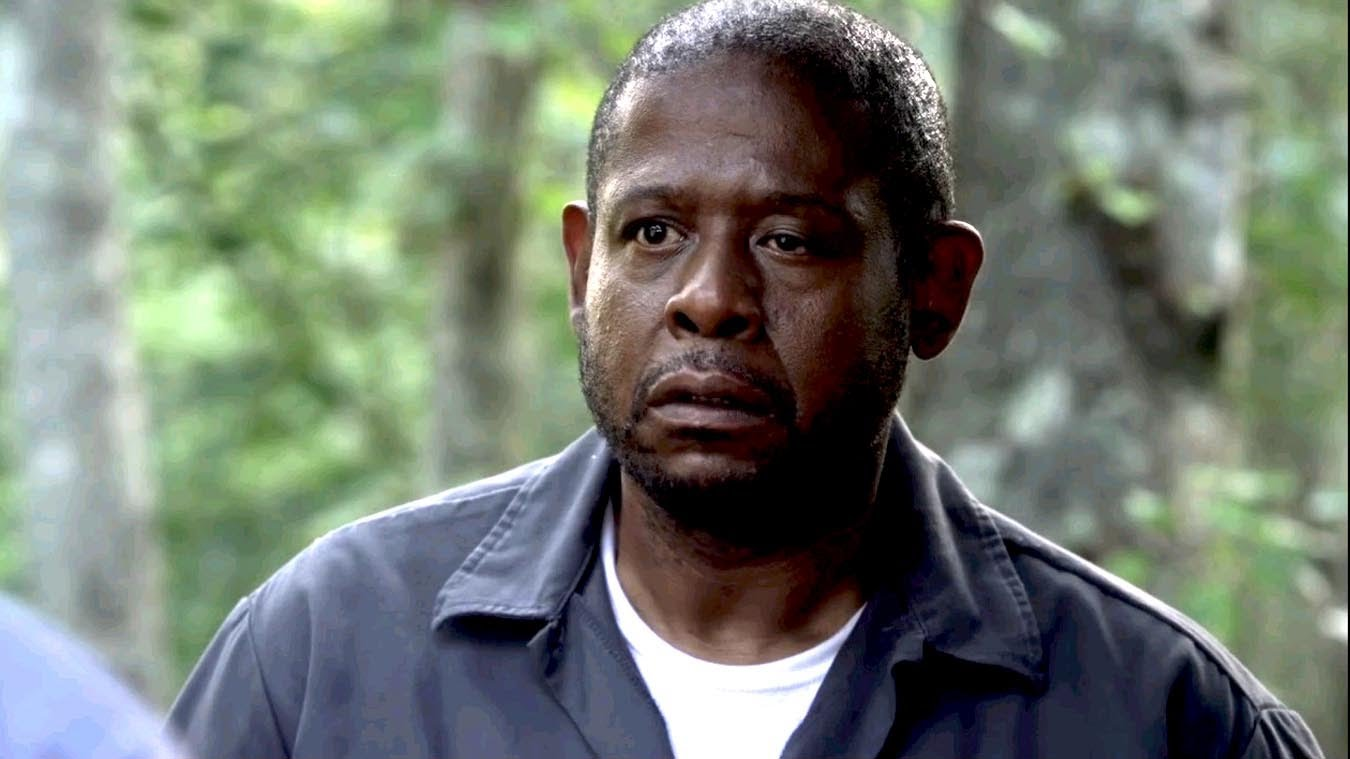How does the setting influence the overall mood of this image? The dense, blurred background of green forest lends a serene yet mysterious aura to the scene. It isolates the character, both physically and metaphorically, underlining a sense of introspection or internal conflict. The contrast between the natural calm of the environment and the character's somber expression intensifies the dramatic effect, painting a mood of tension interlaced with tranquility. 